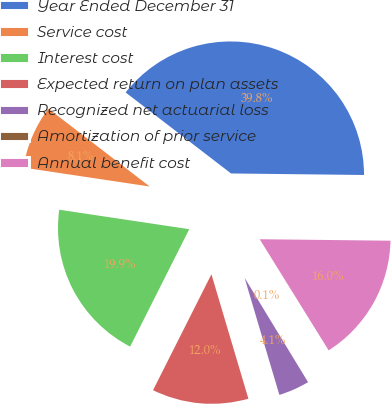Convert chart. <chart><loc_0><loc_0><loc_500><loc_500><pie_chart><fcel>Year Ended December 31<fcel>Service cost<fcel>Interest cost<fcel>Expected return on plan assets<fcel>Recognized net actuarial loss<fcel>Amortization of prior service<fcel>Annual benefit cost<nl><fcel>39.75%<fcel>8.06%<fcel>19.94%<fcel>12.02%<fcel>4.1%<fcel>0.14%<fcel>15.98%<nl></chart> 